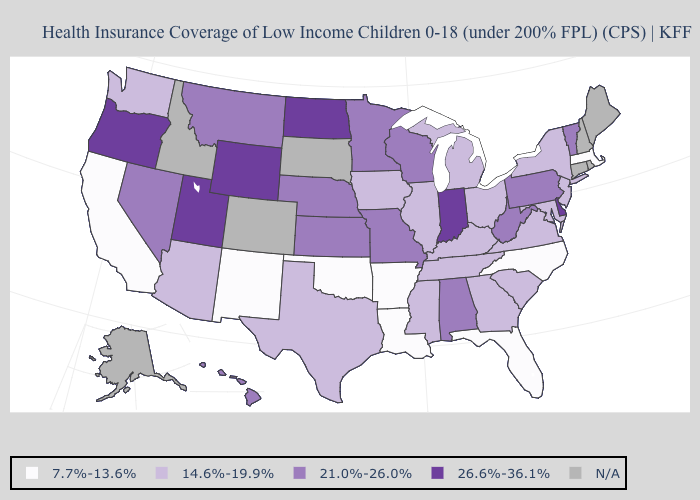What is the value of Massachusetts?
Short answer required. 7.7%-13.6%. Does Illinois have the highest value in the MidWest?
Short answer required. No. What is the value of Idaho?
Short answer required. N/A. Does the first symbol in the legend represent the smallest category?
Quick response, please. Yes. What is the value of Ohio?
Give a very brief answer. 14.6%-19.9%. Name the states that have a value in the range 14.6%-19.9%?
Short answer required. Arizona, Georgia, Illinois, Iowa, Kentucky, Maryland, Michigan, Mississippi, New Jersey, New York, Ohio, South Carolina, Tennessee, Texas, Virginia, Washington. Among the states that border South Carolina , which have the highest value?
Be succinct. Georgia. Among the states that border Massachusetts , does New York have the lowest value?
Keep it brief. Yes. Which states hav the highest value in the South?
Concise answer only. Delaware. Name the states that have a value in the range 26.6%-36.1%?
Be succinct. Delaware, Indiana, North Dakota, Oregon, Utah, Wyoming. What is the value of Maine?
Quick response, please. N/A. Among the states that border Florida , which have the highest value?
Quick response, please. Alabama. Name the states that have a value in the range 26.6%-36.1%?
Keep it brief. Delaware, Indiana, North Dakota, Oregon, Utah, Wyoming. 